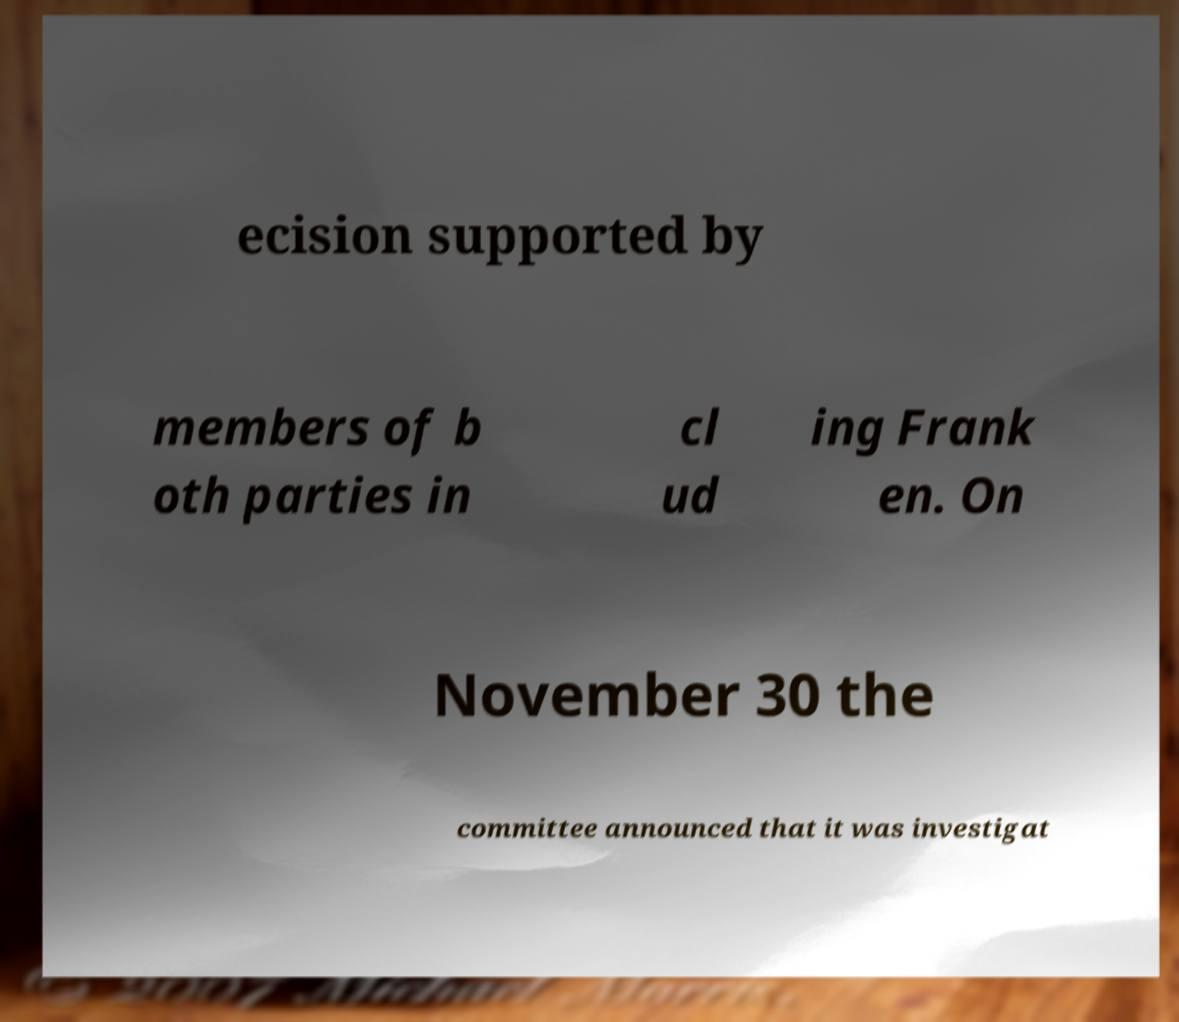Could you extract and type out the text from this image? ecision supported by members of b oth parties in cl ud ing Frank en. On November 30 the committee announced that it was investigat 